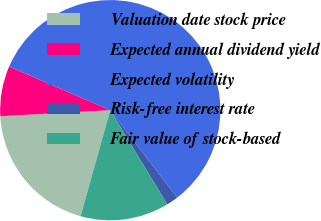Convert chart. <chart><loc_0><loc_0><loc_500><loc_500><pie_chart><fcel>Valuation date stock price<fcel>Expected annual dividend yield<fcel>Expected volatility<fcel>Risk-free interest rate<fcel>Fair value of stock-based<nl><fcel>19.78%<fcel>7.37%<fcel>58.12%<fcel>1.73%<fcel>13.01%<nl></chart> 